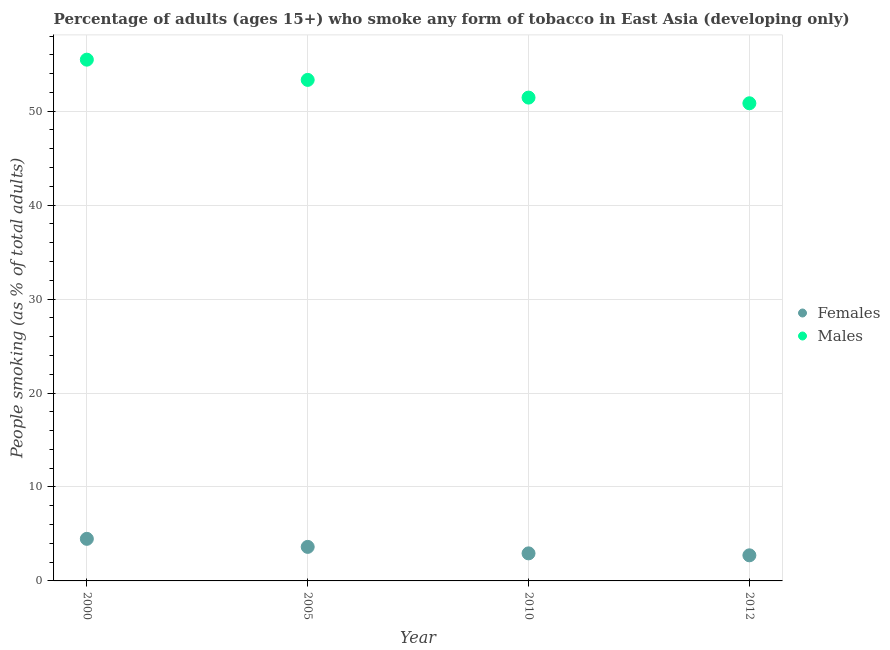What is the percentage of females who smoke in 2010?
Offer a very short reply. 2.93. Across all years, what is the maximum percentage of females who smoke?
Ensure brevity in your answer.  4.48. Across all years, what is the minimum percentage of females who smoke?
Provide a short and direct response. 2.72. In which year was the percentage of females who smoke minimum?
Your response must be concise. 2012. What is the total percentage of males who smoke in the graph?
Provide a short and direct response. 211.11. What is the difference between the percentage of males who smoke in 2000 and that in 2010?
Make the answer very short. 4.04. What is the difference between the percentage of males who smoke in 2010 and the percentage of females who smoke in 2000?
Provide a succinct answer. 46.97. What is the average percentage of males who smoke per year?
Offer a very short reply. 52.78. In the year 2005, what is the difference between the percentage of males who smoke and percentage of females who smoke?
Give a very brief answer. 49.71. In how many years, is the percentage of females who smoke greater than 6 %?
Provide a short and direct response. 0. What is the ratio of the percentage of males who smoke in 2005 to that in 2012?
Give a very brief answer. 1.05. Is the difference between the percentage of males who smoke in 2010 and 2012 greater than the difference between the percentage of females who smoke in 2010 and 2012?
Your answer should be compact. Yes. What is the difference between the highest and the second highest percentage of males who smoke?
Make the answer very short. 2.15. What is the difference between the highest and the lowest percentage of males who smoke?
Keep it short and to the point. 4.64. Is the percentage of females who smoke strictly greater than the percentage of males who smoke over the years?
Keep it short and to the point. No. What is the difference between two consecutive major ticks on the Y-axis?
Offer a very short reply. 10. Are the values on the major ticks of Y-axis written in scientific E-notation?
Make the answer very short. No. Where does the legend appear in the graph?
Make the answer very short. Center right. How many legend labels are there?
Make the answer very short. 2. How are the legend labels stacked?
Give a very brief answer. Vertical. What is the title of the graph?
Ensure brevity in your answer.  Percentage of adults (ages 15+) who smoke any form of tobacco in East Asia (developing only). Does "Urban" appear as one of the legend labels in the graph?
Make the answer very short. No. What is the label or title of the Y-axis?
Keep it short and to the point. People smoking (as % of total adults). What is the People smoking (as % of total adults) of Females in 2000?
Ensure brevity in your answer.  4.48. What is the People smoking (as % of total adults) of Males in 2000?
Keep it short and to the point. 55.49. What is the People smoking (as % of total adults) of Females in 2005?
Your response must be concise. 3.62. What is the People smoking (as % of total adults) of Males in 2005?
Provide a short and direct response. 53.33. What is the People smoking (as % of total adults) in Females in 2010?
Give a very brief answer. 2.93. What is the People smoking (as % of total adults) in Males in 2010?
Provide a succinct answer. 51.45. What is the People smoking (as % of total adults) in Females in 2012?
Offer a terse response. 2.72. What is the People smoking (as % of total adults) in Males in 2012?
Provide a short and direct response. 50.84. Across all years, what is the maximum People smoking (as % of total adults) of Females?
Provide a short and direct response. 4.48. Across all years, what is the maximum People smoking (as % of total adults) of Males?
Make the answer very short. 55.49. Across all years, what is the minimum People smoking (as % of total adults) of Females?
Keep it short and to the point. 2.72. Across all years, what is the minimum People smoking (as % of total adults) in Males?
Your answer should be compact. 50.84. What is the total People smoking (as % of total adults) of Females in the graph?
Give a very brief answer. 13.76. What is the total People smoking (as % of total adults) of Males in the graph?
Your response must be concise. 211.11. What is the difference between the People smoking (as % of total adults) of Females in 2000 and that in 2005?
Make the answer very short. 0.86. What is the difference between the People smoking (as % of total adults) in Males in 2000 and that in 2005?
Keep it short and to the point. 2.15. What is the difference between the People smoking (as % of total adults) in Females in 2000 and that in 2010?
Make the answer very short. 1.55. What is the difference between the People smoking (as % of total adults) of Males in 2000 and that in 2010?
Provide a short and direct response. 4.04. What is the difference between the People smoking (as % of total adults) of Females in 2000 and that in 2012?
Provide a short and direct response. 1.76. What is the difference between the People smoking (as % of total adults) in Males in 2000 and that in 2012?
Your response must be concise. 4.64. What is the difference between the People smoking (as % of total adults) in Females in 2005 and that in 2010?
Offer a terse response. 0.69. What is the difference between the People smoking (as % of total adults) in Males in 2005 and that in 2010?
Make the answer very short. 1.88. What is the difference between the People smoking (as % of total adults) of Females in 2005 and that in 2012?
Offer a very short reply. 0.9. What is the difference between the People smoking (as % of total adults) in Males in 2005 and that in 2012?
Make the answer very short. 2.49. What is the difference between the People smoking (as % of total adults) in Females in 2010 and that in 2012?
Provide a succinct answer. 0.21. What is the difference between the People smoking (as % of total adults) in Males in 2010 and that in 2012?
Offer a terse response. 0.6. What is the difference between the People smoking (as % of total adults) of Females in 2000 and the People smoking (as % of total adults) of Males in 2005?
Provide a short and direct response. -48.85. What is the difference between the People smoking (as % of total adults) of Females in 2000 and the People smoking (as % of total adults) of Males in 2010?
Offer a very short reply. -46.97. What is the difference between the People smoking (as % of total adults) of Females in 2000 and the People smoking (as % of total adults) of Males in 2012?
Ensure brevity in your answer.  -46.36. What is the difference between the People smoking (as % of total adults) of Females in 2005 and the People smoking (as % of total adults) of Males in 2010?
Keep it short and to the point. -47.83. What is the difference between the People smoking (as % of total adults) in Females in 2005 and the People smoking (as % of total adults) in Males in 2012?
Make the answer very short. -47.22. What is the difference between the People smoking (as % of total adults) in Females in 2010 and the People smoking (as % of total adults) in Males in 2012?
Offer a very short reply. -47.91. What is the average People smoking (as % of total adults) in Females per year?
Give a very brief answer. 3.44. What is the average People smoking (as % of total adults) in Males per year?
Your response must be concise. 52.78. In the year 2000, what is the difference between the People smoking (as % of total adults) of Females and People smoking (as % of total adults) of Males?
Your response must be concise. -51.01. In the year 2005, what is the difference between the People smoking (as % of total adults) in Females and People smoking (as % of total adults) in Males?
Offer a terse response. -49.71. In the year 2010, what is the difference between the People smoking (as % of total adults) of Females and People smoking (as % of total adults) of Males?
Make the answer very short. -48.52. In the year 2012, what is the difference between the People smoking (as % of total adults) of Females and People smoking (as % of total adults) of Males?
Make the answer very short. -48.12. What is the ratio of the People smoking (as % of total adults) of Females in 2000 to that in 2005?
Make the answer very short. 1.24. What is the ratio of the People smoking (as % of total adults) of Males in 2000 to that in 2005?
Your answer should be very brief. 1.04. What is the ratio of the People smoking (as % of total adults) of Females in 2000 to that in 2010?
Your response must be concise. 1.53. What is the ratio of the People smoking (as % of total adults) of Males in 2000 to that in 2010?
Ensure brevity in your answer.  1.08. What is the ratio of the People smoking (as % of total adults) of Females in 2000 to that in 2012?
Give a very brief answer. 1.64. What is the ratio of the People smoking (as % of total adults) of Males in 2000 to that in 2012?
Keep it short and to the point. 1.09. What is the ratio of the People smoking (as % of total adults) in Females in 2005 to that in 2010?
Provide a succinct answer. 1.24. What is the ratio of the People smoking (as % of total adults) in Males in 2005 to that in 2010?
Make the answer very short. 1.04. What is the ratio of the People smoking (as % of total adults) of Females in 2005 to that in 2012?
Ensure brevity in your answer.  1.33. What is the ratio of the People smoking (as % of total adults) in Males in 2005 to that in 2012?
Give a very brief answer. 1.05. What is the ratio of the People smoking (as % of total adults) of Females in 2010 to that in 2012?
Give a very brief answer. 1.08. What is the ratio of the People smoking (as % of total adults) of Males in 2010 to that in 2012?
Provide a short and direct response. 1.01. What is the difference between the highest and the second highest People smoking (as % of total adults) in Females?
Keep it short and to the point. 0.86. What is the difference between the highest and the second highest People smoking (as % of total adults) in Males?
Provide a short and direct response. 2.15. What is the difference between the highest and the lowest People smoking (as % of total adults) in Females?
Give a very brief answer. 1.76. What is the difference between the highest and the lowest People smoking (as % of total adults) in Males?
Your response must be concise. 4.64. 